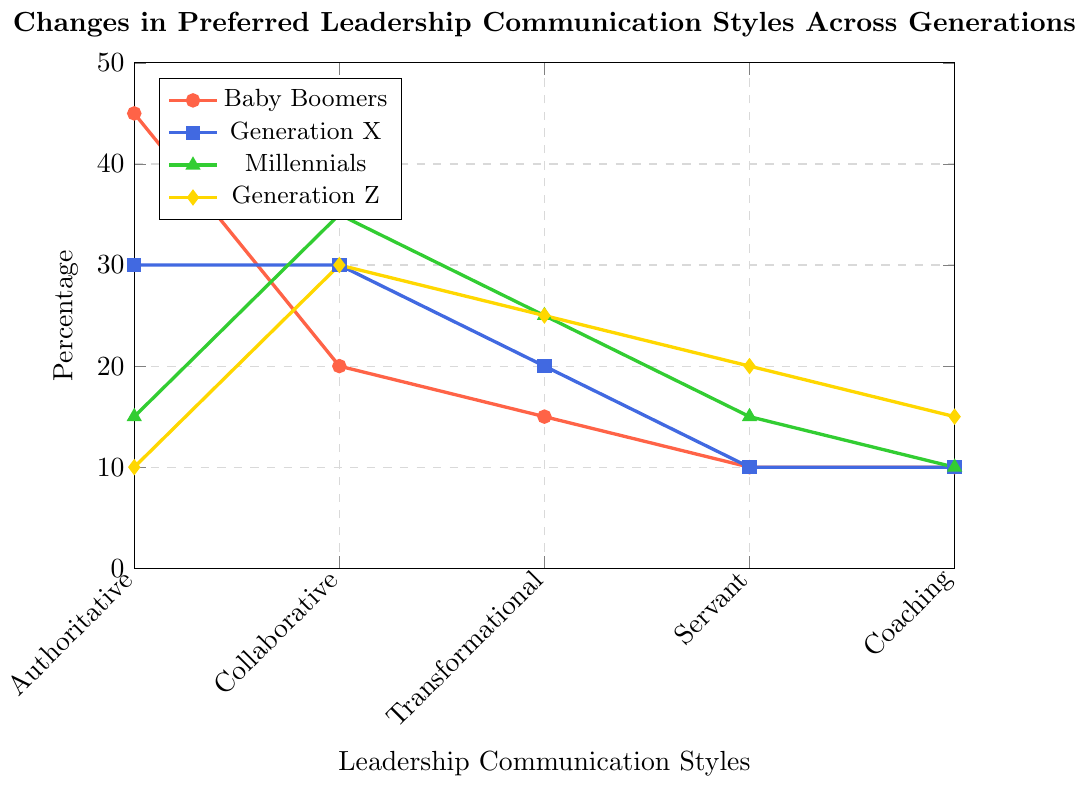What is the preferred leadership communication style for Baby Boomers? To determine the preferred leadership communication style for Baby Boomers, identify the highest value in the Baby Boomers' data points: Authoritative (45), Collaborative (20), Transformational (15), Servant (10), Coaching (10). Authoritative has the highest value.
Answer: Authoritative Which generation prefers the Transformational leadership style the most? Compare the values for Transformational leadership style (the third style) of each generation: Baby Boomers (15), Generation X (20), Millennials (25), Generation Z (25). Both Millennials and Generation Z have the highest value of 25.
Answer: Millennials and Generation Z What is the total percentage of Millennials preferring Collaborative and Coaching styles combined? For Millennials, the values are Collaborative (35) and Coaching (10). Adding these values: 35 + 10 = 45.
Answer: 45 Which leadership style has the lowest preference across Generation X? For Generation X, examine the values for each style: Authoritative (30), Collaborative (30), Transformational (20), Servant (10), Coaching (10). The lowest value is shared by Servant and Coaching with 10 each.
Answer: Servant and Coaching How does the preference for Authoritative leadership between Baby Boomers and Generation Z compare? Compare the Authoritative values: Baby Boomers (45) and Generation Z (10). Subtract the value of Generation Z from Baby Boomers: 45 - 10 = 35. Baby Boomers prefer Authoritative leadership 35% more than Generation Z.
Answer: Baby Boomers prefer it 35% more What is the average preference for Transformational leadership style across all generations? Calculate the average of the Transformational values: (15 + 20 + 25 + 25)/4 = 85/4 = 21.25.
Answer: 21.25 What is Generation X's preference for Collaborative leadership compared to Baby Boomers? Compare the Collaborative values: Generation X (30) and Baby Boomers (20). Subtract the value of Baby Boomers from Generation X: 30 - 20 = 10. Generation X prefers Collaborative leadership 10% more than Baby Boomers.
Answer: 10% more Which generation has the most balanced preference across all leadership styles? To determine balance, consider how evenly values are distributed. Baby Boomers have a large spread (45, 20, 15, 10, 10), Generation X is more balanced (30, 30, 20, 10, 10), Millennials vary more (15, 35, 25, 15, 10), Generation Z is fairly balanced (10, 30, 25, 20, 15). Generation X shows the smallest range between highest and lowest preferences.
Answer: Generation X What is the difference in preference for Servant leadership between Millennials and Generation Z? Compare the Servant values: Millennials (15) and Generation Z (20). Subtract the value of Millennials from Generation Z: 20 - 15 = 5. Generation Z prefers Servant leadership 5% more than Millennials.
Answer: 5% more 